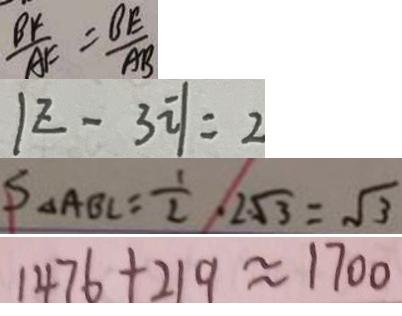Convert formula to latex. <formula><loc_0><loc_0><loc_500><loc_500>\frac { B F } { A F } = \frac { B E } { A B } 
 \vert z - 3 i \vert = 2 
 S _ { \Delta } A B C = \frac { 1 } { 2 } , 2 \sqrt { 3 } = \sqrt { 3 } 
 1 4 7 6 + 2 1 9 \approx 1 7 0 0</formula> 